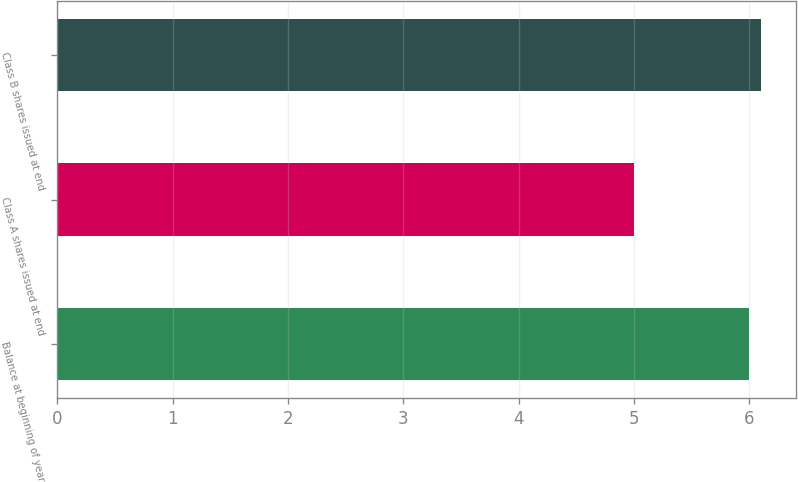Convert chart to OTSL. <chart><loc_0><loc_0><loc_500><loc_500><bar_chart><fcel>Balance at beginning of year<fcel>Class A shares issued at end<fcel>Class B shares issued at end<nl><fcel>6<fcel>5<fcel>6.1<nl></chart> 